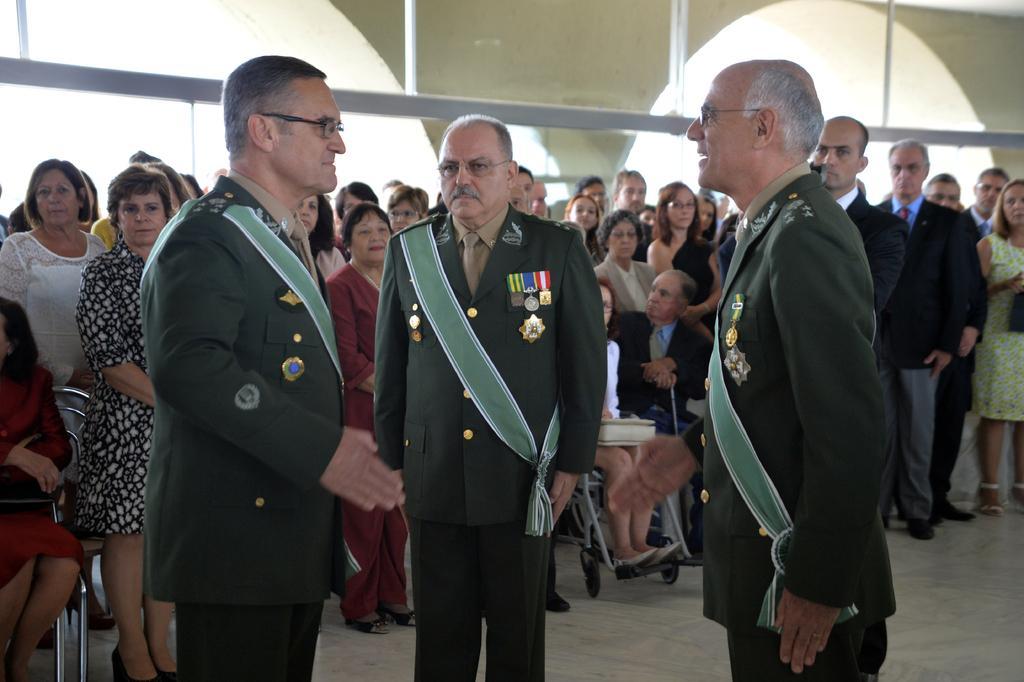Could you give a brief overview of what you see in this image? In this picture I can observe some people standing on the floor. There are men and women in this picture. 